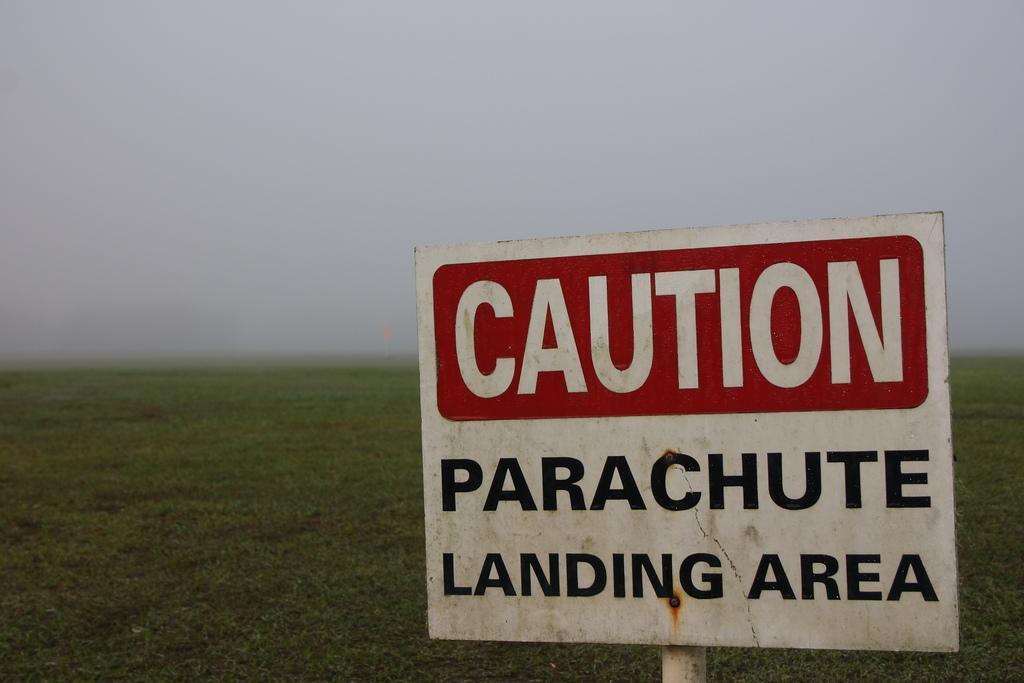In one or two sentences, can you explain what this image depicts? In this picture we can see a board on which some words are written, behind we can see some grass. 